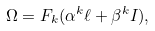Convert formula to latex. <formula><loc_0><loc_0><loc_500><loc_500>\Omega = F _ { k } ( \alpha ^ { k } \ell + \beta ^ { k } I ) ,</formula> 